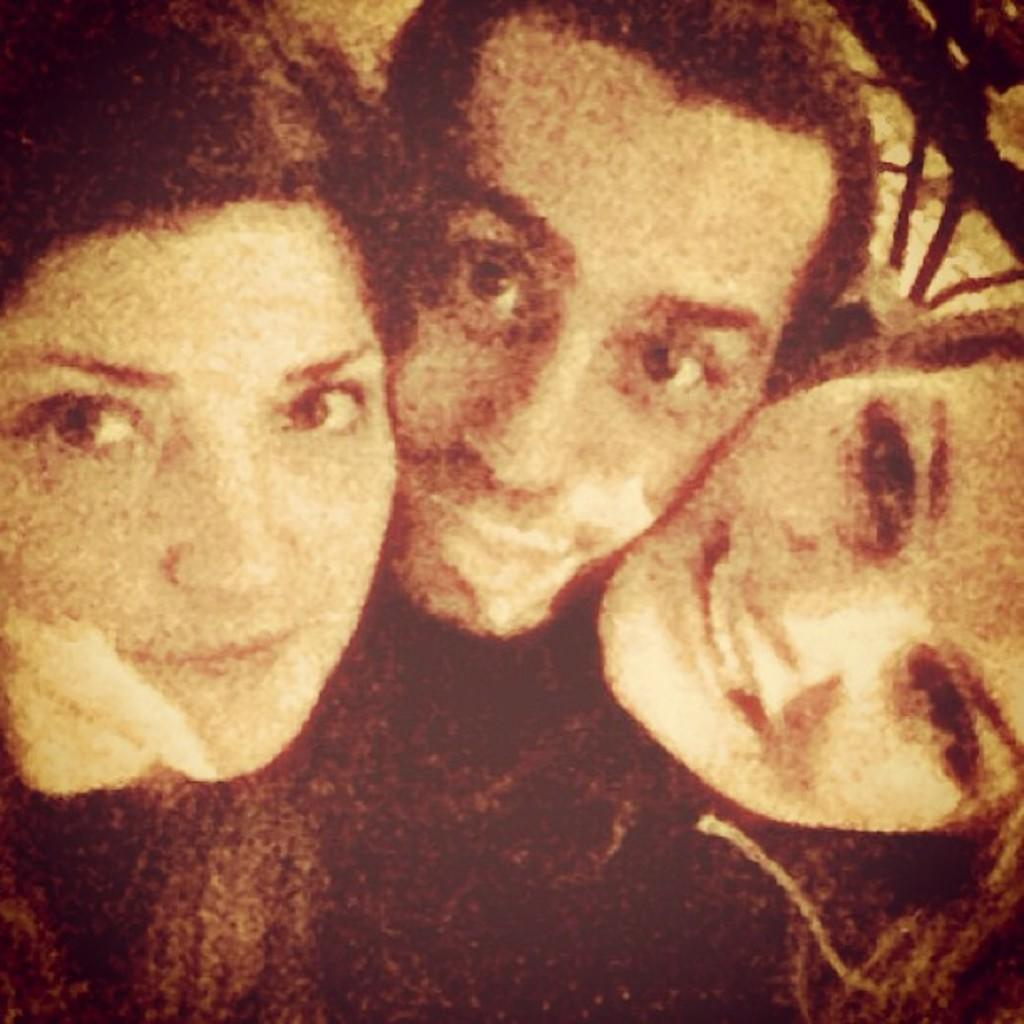How many people are present in the image? There are three people in the image. What can be seen in the background or surrounding the people? There is railing visible in the image. Can you tell if any editing has been done to the image? Yes, the image has been edited. Where is the drain located in the image? There is no drain present in the image. What type of wish can be granted by looking at the image? The image does not have any magical properties, so no wishes can be granted by looking at it. 